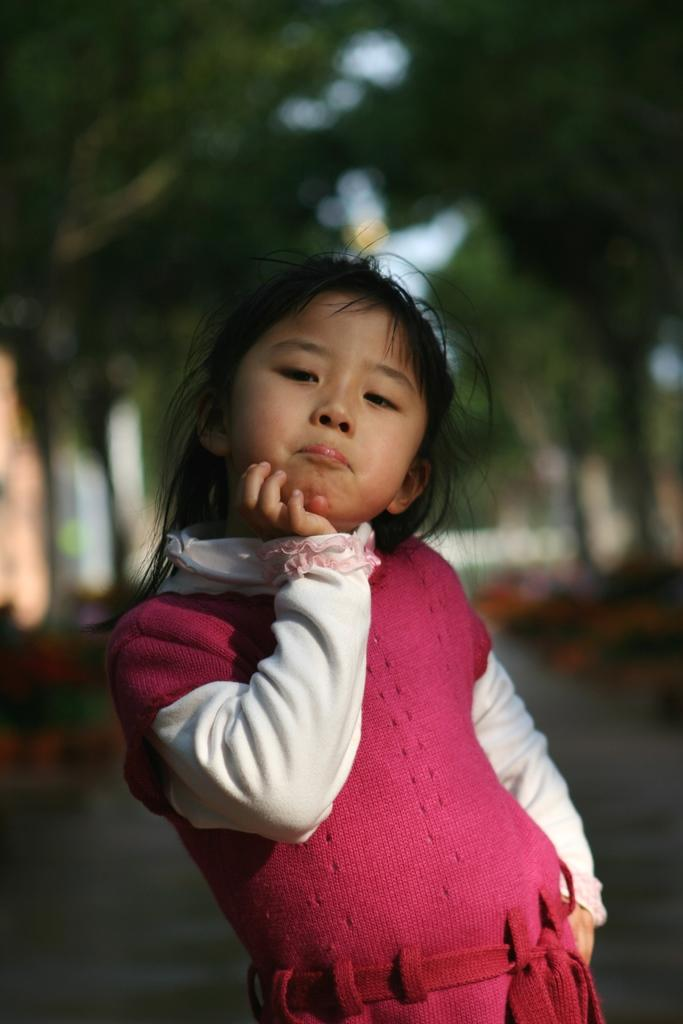What is the main subject of the image? There is a person standing in the image. Can you describe the person's clothing? The person is wearing a pink and white color dress. What can be seen in the background of the image? There are many trees in the background of the image, but they are blurry. What type of seed is the person holding in the image? There is no seed present in the image; the person is not holding anything. Are there any men visible in the image? The image only shows a person wearing a pink and white color dress, and there is no indication of the person's gender. 